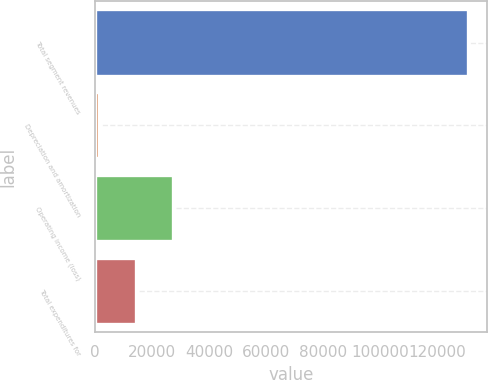Convert chart to OTSL. <chart><loc_0><loc_0><loc_500><loc_500><bar_chart><fcel>Total segment revenues<fcel>Depreciation and amortization<fcel>Operating income (loss)<fcel>Total expenditures for<nl><fcel>130844<fcel>1690<fcel>27520.8<fcel>14605.4<nl></chart> 